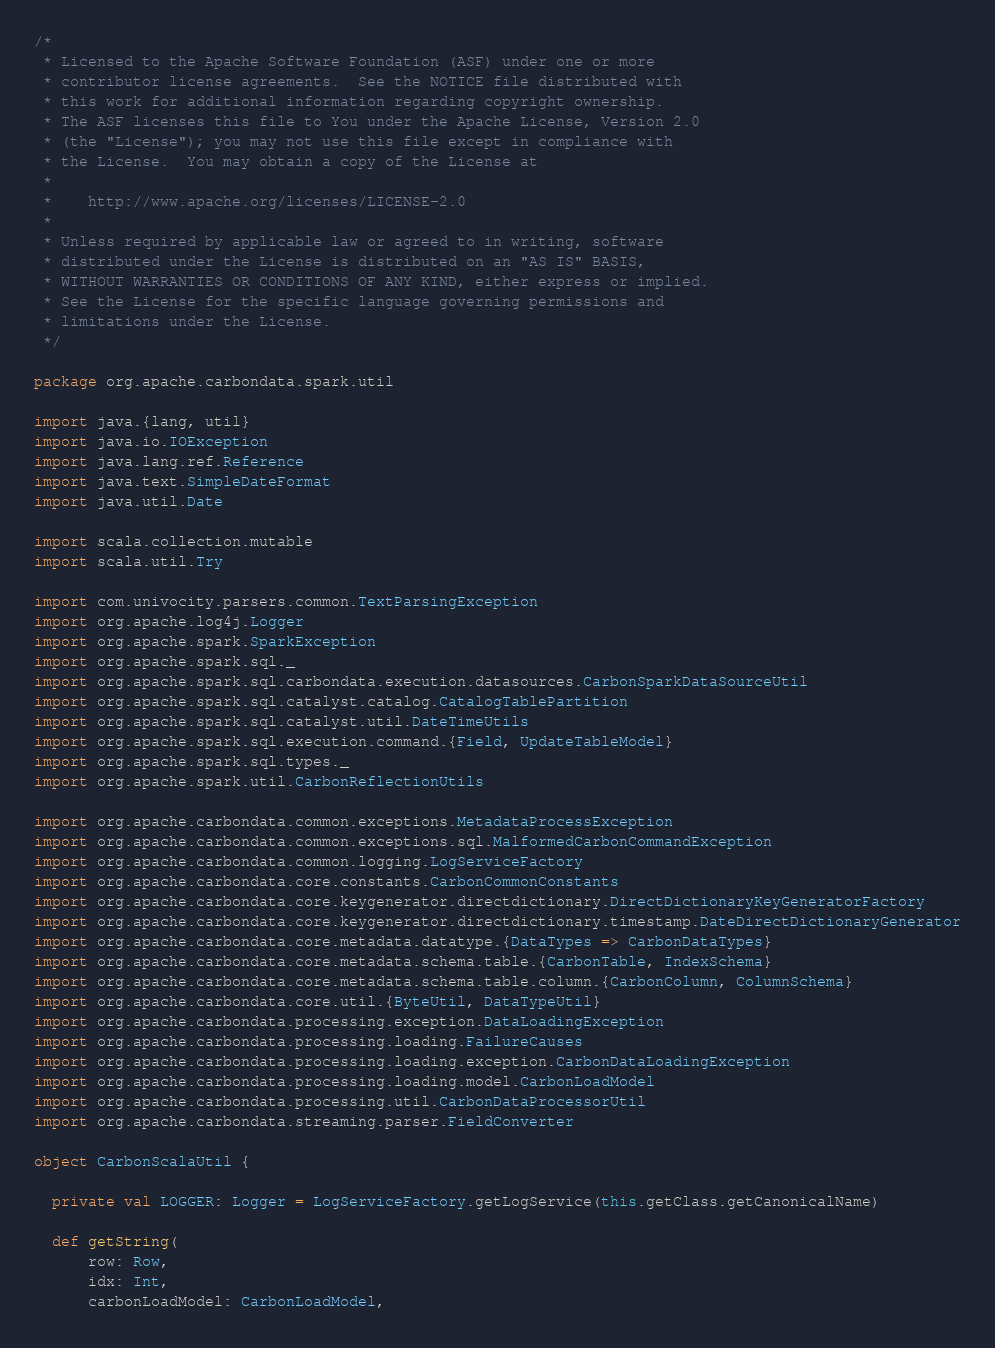Convert code to text. <code><loc_0><loc_0><loc_500><loc_500><_Scala_>/*
 * Licensed to the Apache Software Foundation (ASF) under one or more
 * contributor license agreements.  See the NOTICE file distributed with
 * this work for additional information regarding copyright ownership.
 * The ASF licenses this file to You under the Apache License, Version 2.0
 * (the "License"); you may not use this file except in compliance with
 * the License.  You may obtain a copy of the License at
 *
 *    http://www.apache.org/licenses/LICENSE-2.0
 *
 * Unless required by applicable law or agreed to in writing, software
 * distributed under the License is distributed on an "AS IS" BASIS,
 * WITHOUT WARRANTIES OR CONDITIONS OF ANY KIND, either express or implied.
 * See the License for the specific language governing permissions and
 * limitations under the License.
 */

package org.apache.carbondata.spark.util

import java.{lang, util}
import java.io.IOException
import java.lang.ref.Reference
import java.text.SimpleDateFormat
import java.util.Date

import scala.collection.mutable
import scala.util.Try

import com.univocity.parsers.common.TextParsingException
import org.apache.log4j.Logger
import org.apache.spark.SparkException
import org.apache.spark.sql._
import org.apache.spark.sql.carbondata.execution.datasources.CarbonSparkDataSourceUtil
import org.apache.spark.sql.catalyst.catalog.CatalogTablePartition
import org.apache.spark.sql.catalyst.util.DateTimeUtils
import org.apache.spark.sql.execution.command.{Field, UpdateTableModel}
import org.apache.spark.sql.types._
import org.apache.spark.util.CarbonReflectionUtils

import org.apache.carbondata.common.exceptions.MetadataProcessException
import org.apache.carbondata.common.exceptions.sql.MalformedCarbonCommandException
import org.apache.carbondata.common.logging.LogServiceFactory
import org.apache.carbondata.core.constants.CarbonCommonConstants
import org.apache.carbondata.core.keygenerator.directdictionary.DirectDictionaryKeyGeneratorFactory
import org.apache.carbondata.core.keygenerator.directdictionary.timestamp.DateDirectDictionaryGenerator
import org.apache.carbondata.core.metadata.datatype.{DataTypes => CarbonDataTypes}
import org.apache.carbondata.core.metadata.schema.table.{CarbonTable, IndexSchema}
import org.apache.carbondata.core.metadata.schema.table.column.{CarbonColumn, ColumnSchema}
import org.apache.carbondata.core.util.{ByteUtil, DataTypeUtil}
import org.apache.carbondata.processing.exception.DataLoadingException
import org.apache.carbondata.processing.loading.FailureCauses
import org.apache.carbondata.processing.loading.exception.CarbonDataLoadingException
import org.apache.carbondata.processing.loading.model.CarbonLoadModel
import org.apache.carbondata.processing.util.CarbonDataProcessorUtil
import org.apache.carbondata.streaming.parser.FieldConverter

object CarbonScalaUtil {

  private val LOGGER: Logger = LogServiceFactory.getLogService(this.getClass.getCanonicalName)

  def getString(
      row: Row,
      idx: Int,
      carbonLoadModel: CarbonLoadModel,</code> 